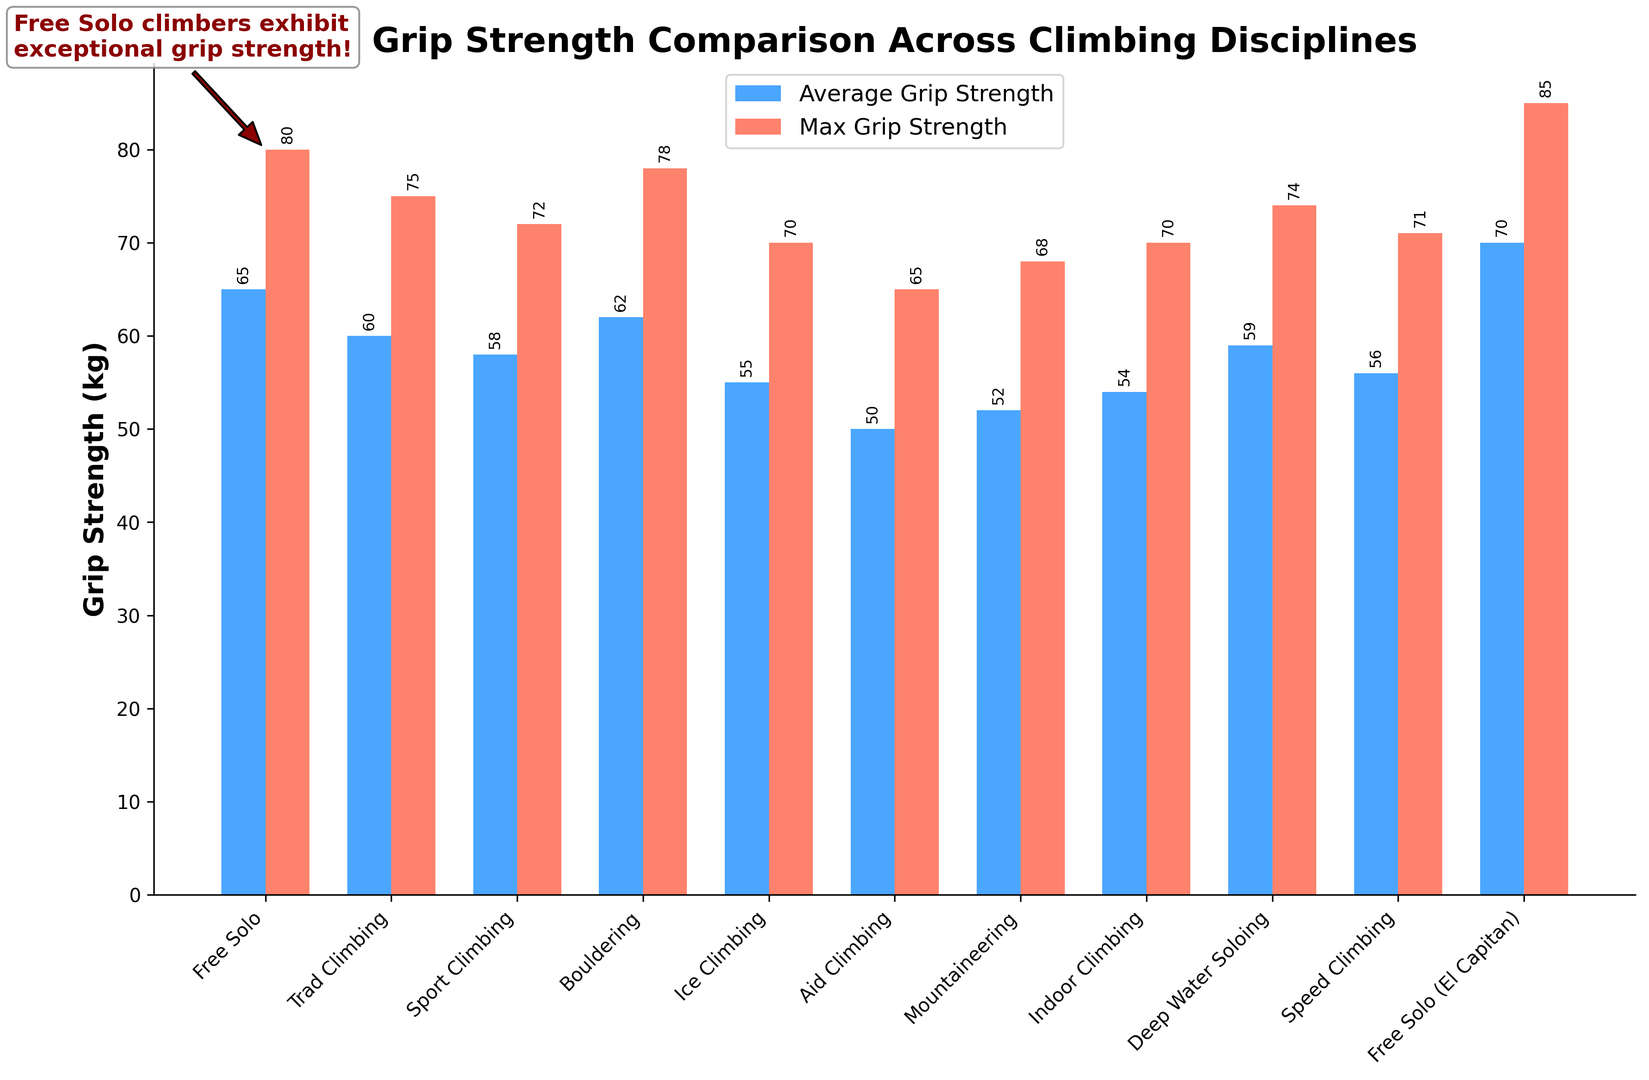What's the average grip strength of Free Solo climbers? The figure shows the average grip strength of various disciplines. Looking at Free Solo, the bar height and annotation indicate an average grip strength of 65 kg.
Answer: 65 kg Which climbing discipline has the lowest average grip strength? The figure shows bars representing the average grip strength for different climbing disciplines. Aid Climbing has the shortest bar and the annotation on it reads 50 kg, indicating the lowest average grip strength among the disciplines.
Answer: Aid Climbing What is the difference in max grip strength between Free Solo climbing and Bouldering? The max grip strength for Free Solo is 80 kg, and the max grip strength for Bouldering is 78 kg. The difference is 80 - 78 = 2 kg.
Answer: 2 kg Which discipline requires higher grip strength, Ice Climbing or Sport Climbing, based on max grip strength? Comparing the heights of the red bars for max grip strength, Ice Climbing has 70 kg while Sport Climbing has 72 kg. Sport Climbing requires higher max grip strength.
Answer: Sport Climbing How many disciplines have an average grip strength of 60 kg or higher? The labels and annotations on the blue bars indicate the average grip strengths. Free Solo (65 kg), Trad Climbing (60 kg), Bouldering (62 kg), Deep Water Soloing (59 kg does not count), and Free Solo (El Capitan) (70 kg) meet or exceed 60 kg. Counting these, there are 4 disciplines.
Answer: 4 What is the total max grip strength for Speed Climbing, Indoor Climbing, and Mountaineering? The max grip strengths are Speed Climbing (71 kg), Indoor Climbing (70 kg), and Mountaineering (68 kg). Summing these values gives 71 + 70 + 68 = 209 kg.
Answer: 209 kg How much more is the max grip strength of Free Solo (El Capitan) compared to Aid Climbing? The max grip strength for Free Solo (El Capitan) is 85 kg and for Aid Climbing it is 65 kg. The difference is 85 - 65 = 20 kg.
Answer: 20 kg Which discipline has a visually annotated text, and what does it highlight? There is an annotation on the figure pointing to the Free Solo discipline. The text highlights the exceptional grip strength required for Free Solo climbers, stating "Free Solo climbers exhibit exceptional grip strength!"
Answer: Free Solo Is the average grip strength for Free Solo (El Capitan) higher than for Traditional Climbing? The average grip strength for Free Solo (El Capitan) is 70 kg, and for Traditional Climbing it is 60 kg. 70 kg is higher than 60 kg.
Answer: Yes What's the average of the maximum grip strengths for Free Solo, Sport Climbing, and Deep Water Soloing? The max grip strengths are Free Solo (80 kg), Sport Climbing (72 kg), and Deep Water Soloing (74 kg). The average is calculated as (80 + 72 + 74) / 3 = 226 / 3 ≈ 75.33 kg.
Answer: ≈ 75.33 kg 